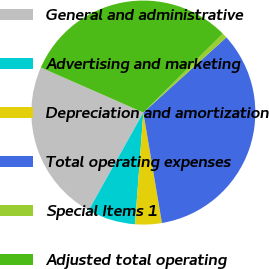Convert chart. <chart><loc_0><loc_0><loc_500><loc_500><pie_chart><fcel>General and administrative<fcel>Advertising and marketing<fcel>Depreciation and amortization<fcel>Total operating expenses<fcel>Special Items 1<fcel>Adjusted total operating<nl><fcel>23.48%<fcel>6.93%<fcel>3.84%<fcel>34.06%<fcel>0.74%<fcel>30.96%<nl></chart> 